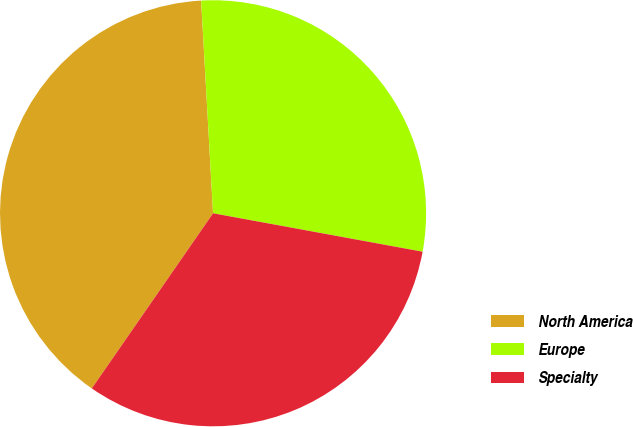<chart> <loc_0><loc_0><loc_500><loc_500><pie_chart><fcel>North America<fcel>Europe<fcel>Specialty<nl><fcel>39.47%<fcel>28.78%<fcel>31.75%<nl></chart> 